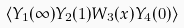<formula> <loc_0><loc_0><loc_500><loc_500>\langle Y _ { 1 } ( \infty ) Y _ { 2 } ( 1 ) W _ { 3 } ( x ) Y _ { 4 } ( 0 ) \rangle</formula> 